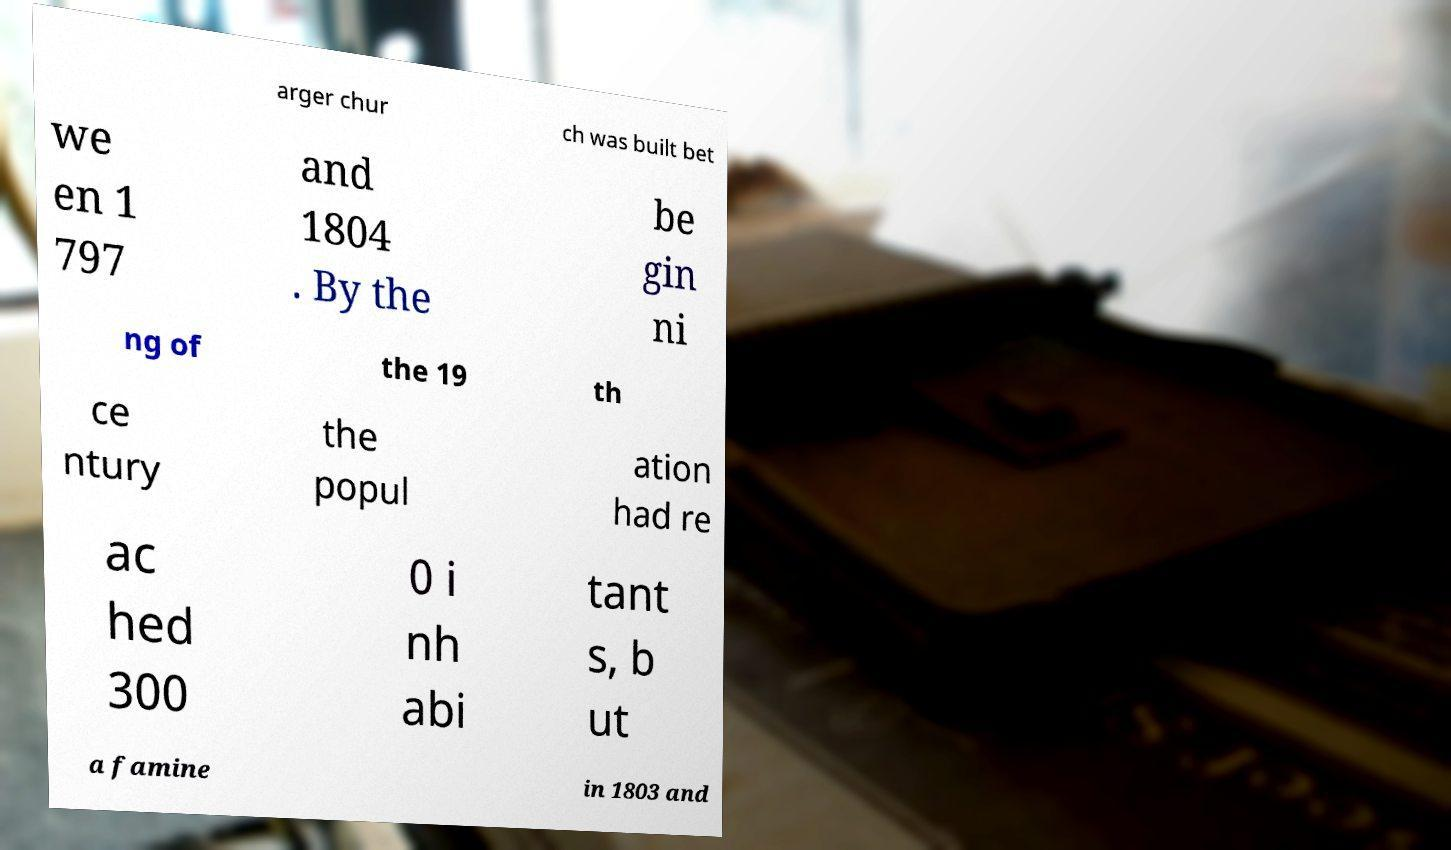Please read and relay the text visible in this image. What does it say? arger chur ch was built bet we en 1 797 and 1804 . By the be gin ni ng of the 19 th ce ntury the popul ation had re ac hed 300 0 i nh abi tant s, b ut a famine in 1803 and 